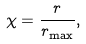Convert formula to latex. <formula><loc_0><loc_0><loc_500><loc_500>\chi = \frac { r } { r _ { \max } } ,</formula> 